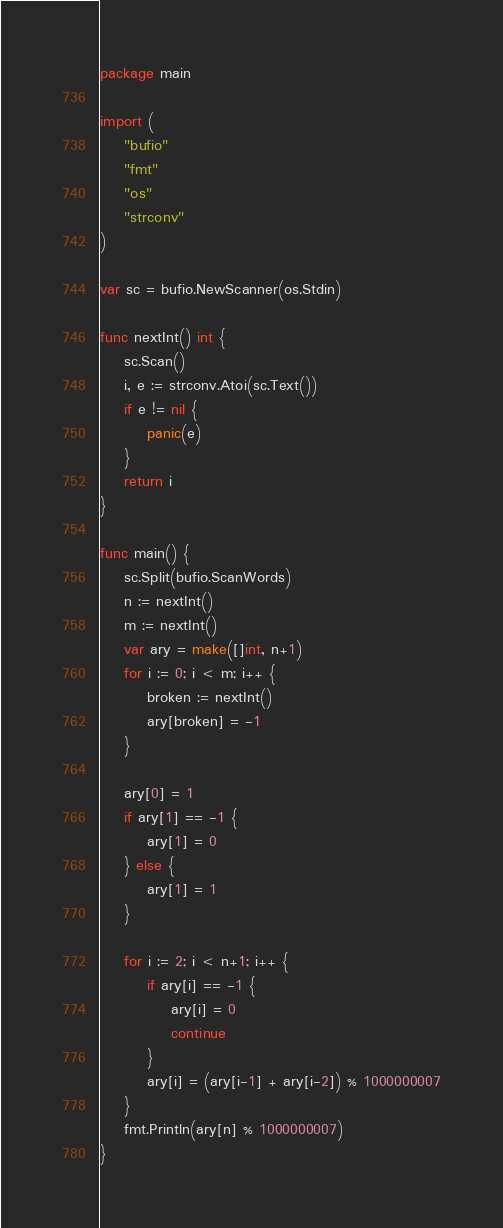Convert code to text. <code><loc_0><loc_0><loc_500><loc_500><_Go_>package main

import (
	"bufio"
	"fmt"
	"os"
	"strconv"
)

var sc = bufio.NewScanner(os.Stdin)

func nextInt() int {
	sc.Scan()
	i, e := strconv.Atoi(sc.Text())
	if e != nil {
		panic(e)
	}
	return i
}

func main() {
	sc.Split(bufio.ScanWords)
	n := nextInt()
	m := nextInt()
	var ary = make([]int, n+1)
	for i := 0; i < m; i++ {
		broken := nextInt()
		ary[broken] = -1
	}

	ary[0] = 1
	if ary[1] == -1 {
		ary[1] = 0
	} else {
		ary[1] = 1
	}

	for i := 2; i < n+1; i++ {
		if ary[i] == -1 {
			ary[i] = 0
			continue
		}
		ary[i] = (ary[i-1] + ary[i-2]) % 1000000007
	}
	fmt.Println(ary[n] % 1000000007)
}
</code> 